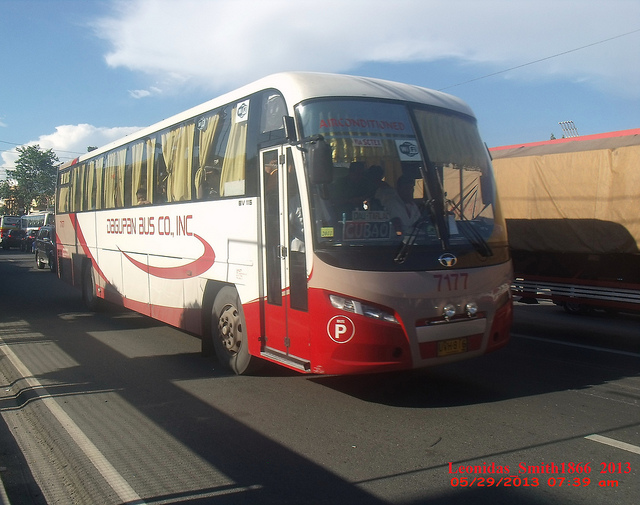<image>What company logo is on the top left of the truck window? It is unknown what the company logo is on the top left of the truck window. What company logo is on the top left of the truck window? I am not sure what company logo is on the top left of the truck window. It can be seen 'swirl line', 'dagupan bus co', 'bus co', 'supreme' or 'p'. 